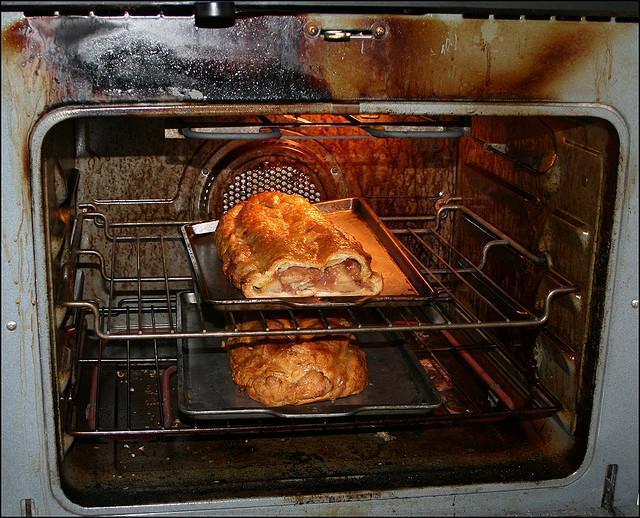How many cars on the locomotive have unprotected wheels?
Give a very brief answer. 0. 